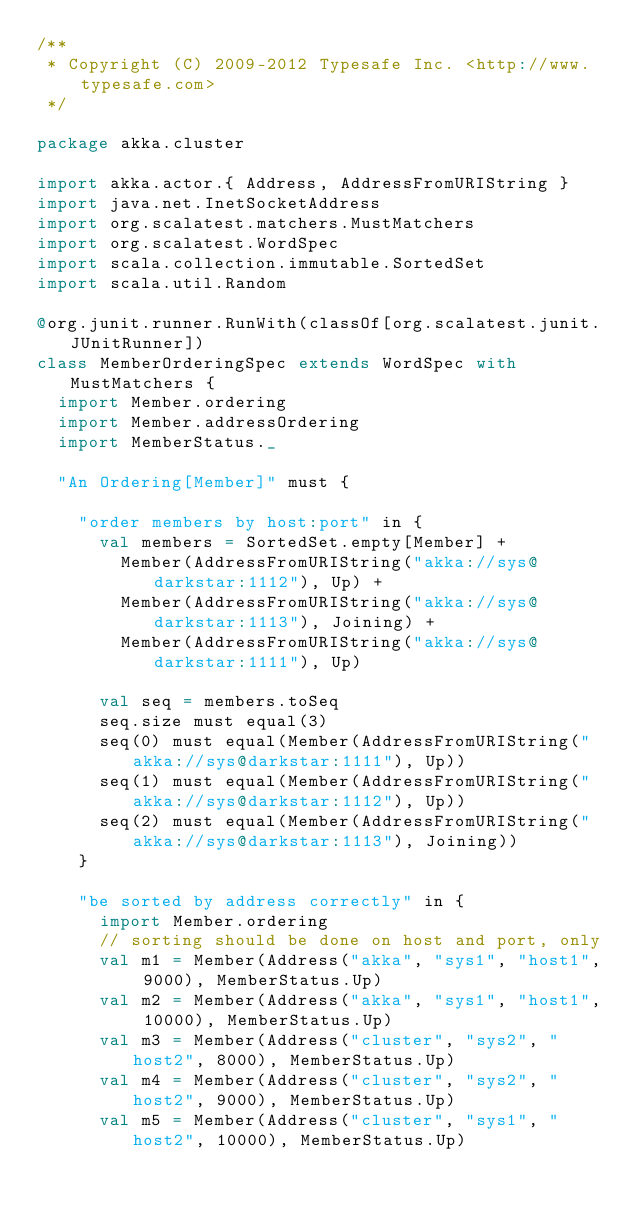Convert code to text. <code><loc_0><loc_0><loc_500><loc_500><_Scala_>/**
 * Copyright (C) 2009-2012 Typesafe Inc. <http://www.typesafe.com>
 */

package akka.cluster

import akka.actor.{ Address, AddressFromURIString }
import java.net.InetSocketAddress
import org.scalatest.matchers.MustMatchers
import org.scalatest.WordSpec
import scala.collection.immutable.SortedSet
import scala.util.Random

@org.junit.runner.RunWith(classOf[org.scalatest.junit.JUnitRunner])
class MemberOrderingSpec extends WordSpec with MustMatchers {
  import Member.ordering
  import Member.addressOrdering
  import MemberStatus._

  "An Ordering[Member]" must {

    "order members by host:port" in {
      val members = SortedSet.empty[Member] +
        Member(AddressFromURIString("akka://sys@darkstar:1112"), Up) +
        Member(AddressFromURIString("akka://sys@darkstar:1113"), Joining) +
        Member(AddressFromURIString("akka://sys@darkstar:1111"), Up)

      val seq = members.toSeq
      seq.size must equal(3)
      seq(0) must equal(Member(AddressFromURIString("akka://sys@darkstar:1111"), Up))
      seq(1) must equal(Member(AddressFromURIString("akka://sys@darkstar:1112"), Up))
      seq(2) must equal(Member(AddressFromURIString("akka://sys@darkstar:1113"), Joining))
    }

    "be sorted by address correctly" in {
      import Member.ordering
      // sorting should be done on host and port, only
      val m1 = Member(Address("akka", "sys1", "host1", 9000), MemberStatus.Up)
      val m2 = Member(Address("akka", "sys1", "host1", 10000), MemberStatus.Up)
      val m3 = Member(Address("cluster", "sys2", "host2", 8000), MemberStatus.Up)
      val m4 = Member(Address("cluster", "sys2", "host2", 9000), MemberStatus.Up)
      val m5 = Member(Address("cluster", "sys1", "host2", 10000), MemberStatus.Up)
</code> 